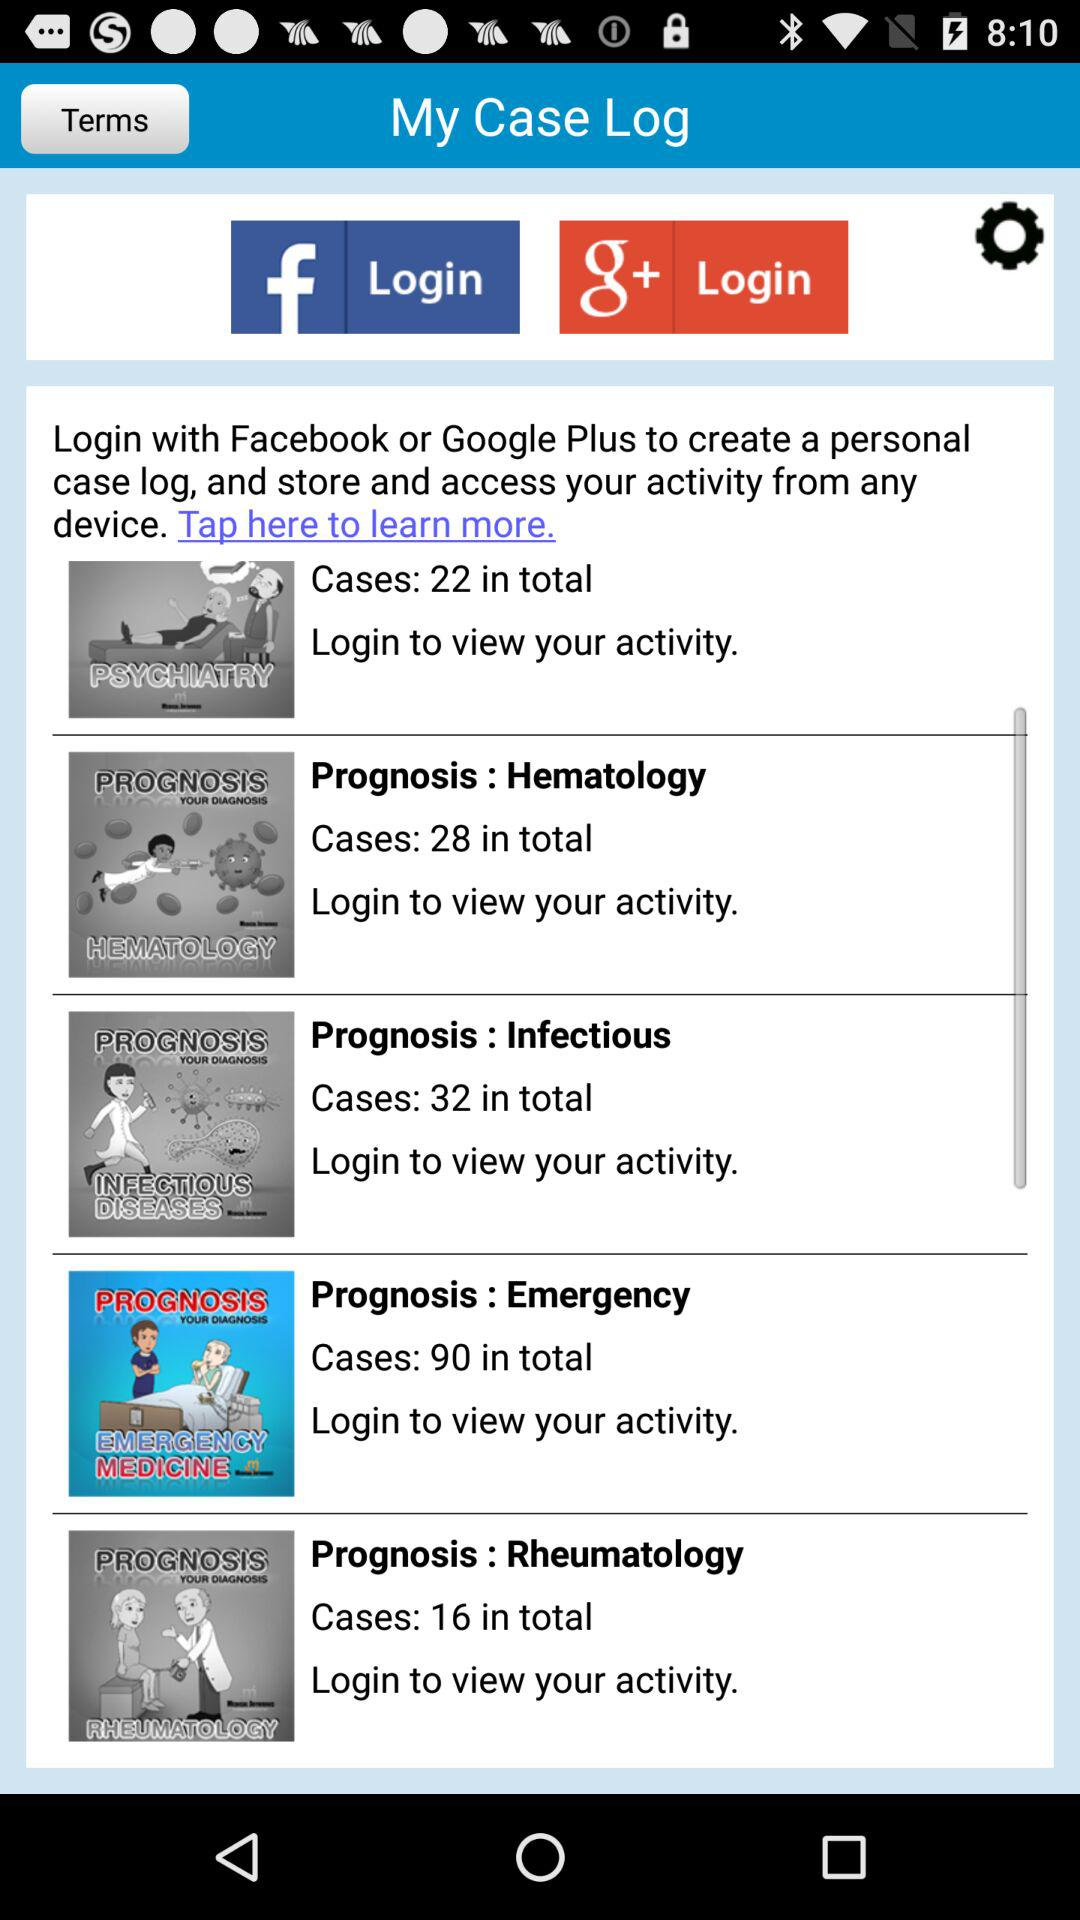How many cases are there in total for the prognosis Infectious?
Answer the question using a single word or phrase. 32 